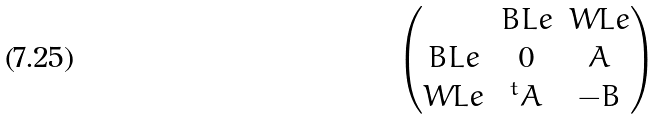Convert formula to latex. <formula><loc_0><loc_0><loc_500><loc_500>\begin{pmatrix} & B L e & W L e \\ B L e & 0 & \bar { A } \\ W L e & ^ { t } \bar { A } & - \bar { B } \end{pmatrix}</formula> 